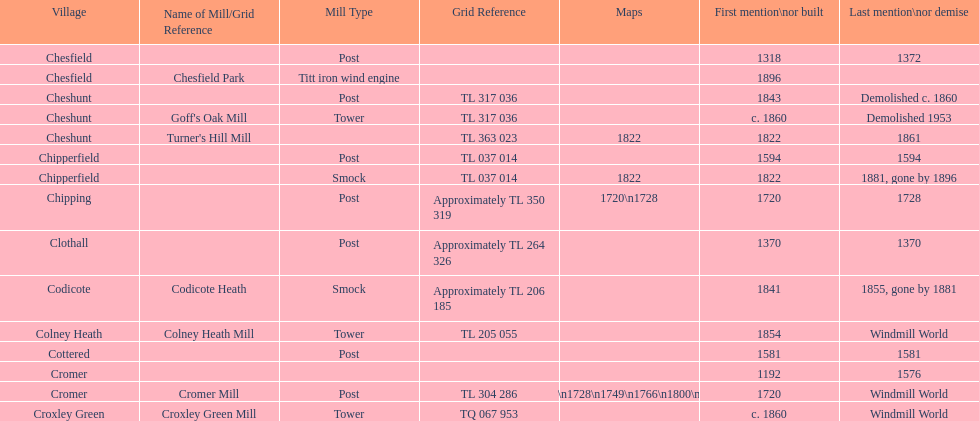What location has the most maps? Cromer. 